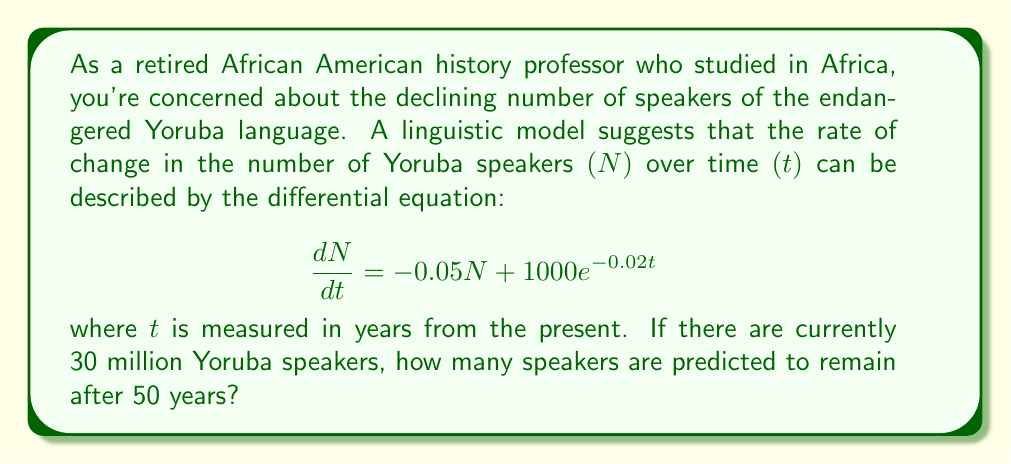Show me your answer to this math problem. To solve this problem, we need to follow these steps:

1) First, we recognize this as a first-order linear differential equation with a time-dependent coefficient in the non-homogeneous term.

2) The general solution for this type of equation is:

   $$N(t) = e^{-0.05t}(C + \int 1000e^{-0.02t} \cdot e^{0.05t}dt)$$

   where $C$ is a constant of integration.

3) Let's solve the integral:

   $$\int 1000e^{-0.02t} \cdot e^{0.05t}dt = 1000\int e^{0.03t}dt = \frac{1000}{0.03}e^{0.03t} + K$$

4) Substituting this back into our general solution:

   $$N(t) = e^{-0.05t}(C + \frac{1000}{0.03}e^{0.03t} + K) = Ce^{-0.05t} + \frac{1000}{0.03}e^{-0.02t} + Ke^{-0.05t}$$

5) We can combine the constants $C$ and $K$ into a single constant, which we'll call $A$:

   $$N(t) = Ae^{-0.05t} + \frac{1000}{0.03}e^{-0.02t}$$

6) Now we use the initial condition: $N(0) = 30,000,000$

   $$30,000,000 = A + \frac{1000}{0.03} = A + 33,333,333.33$$

   $$A = -3,333,333.33$$

7) Our particular solution is:

   $$N(t) = -3,333,333.33e^{-0.05t} + 33,333,333.33e^{-0.02t}$$

8) To find $N(50)$, we substitute $t=50$:

   $$N(50) = -3,333,333.33e^{-0.05(50)} + 33,333,333.33e^{-0.02(50)}$$

9) Calculating this:

   $$N(50) = -3,333,333.33 \cdot 0.0821 + 33,333,333.33 \cdot 0.3679$$
   $$= -273,666.67 + 12,263,333.33$$
   $$= 11,989,666.66$$

Therefore, after 50 years, the model predicts approximately 11,989,667 Yoruba speakers.
Answer: 11,989,667 Yoruba speakers 